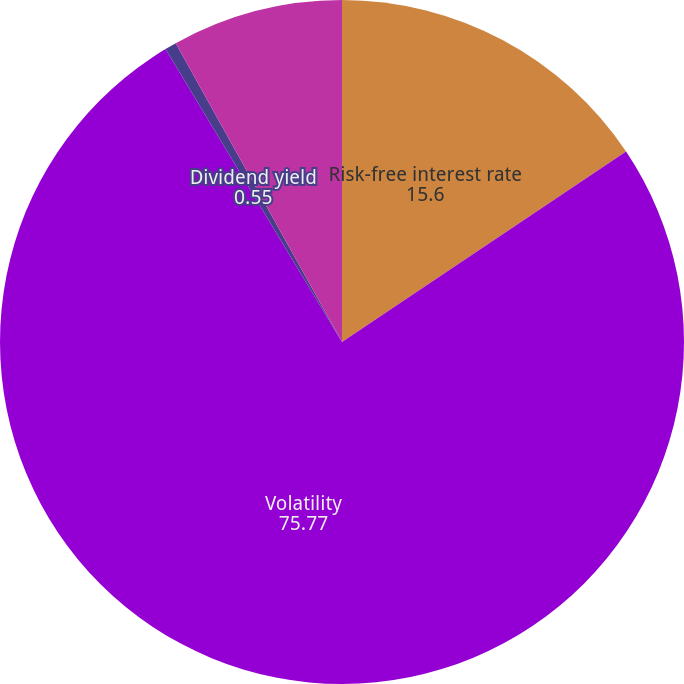Convert chart to OTSL. <chart><loc_0><loc_0><loc_500><loc_500><pie_chart><fcel>Risk-free interest rate<fcel>Volatility<fcel>Dividend yield<fcel>Expected life (years)<nl><fcel>15.6%<fcel>75.77%<fcel>0.55%<fcel>8.08%<nl></chart> 